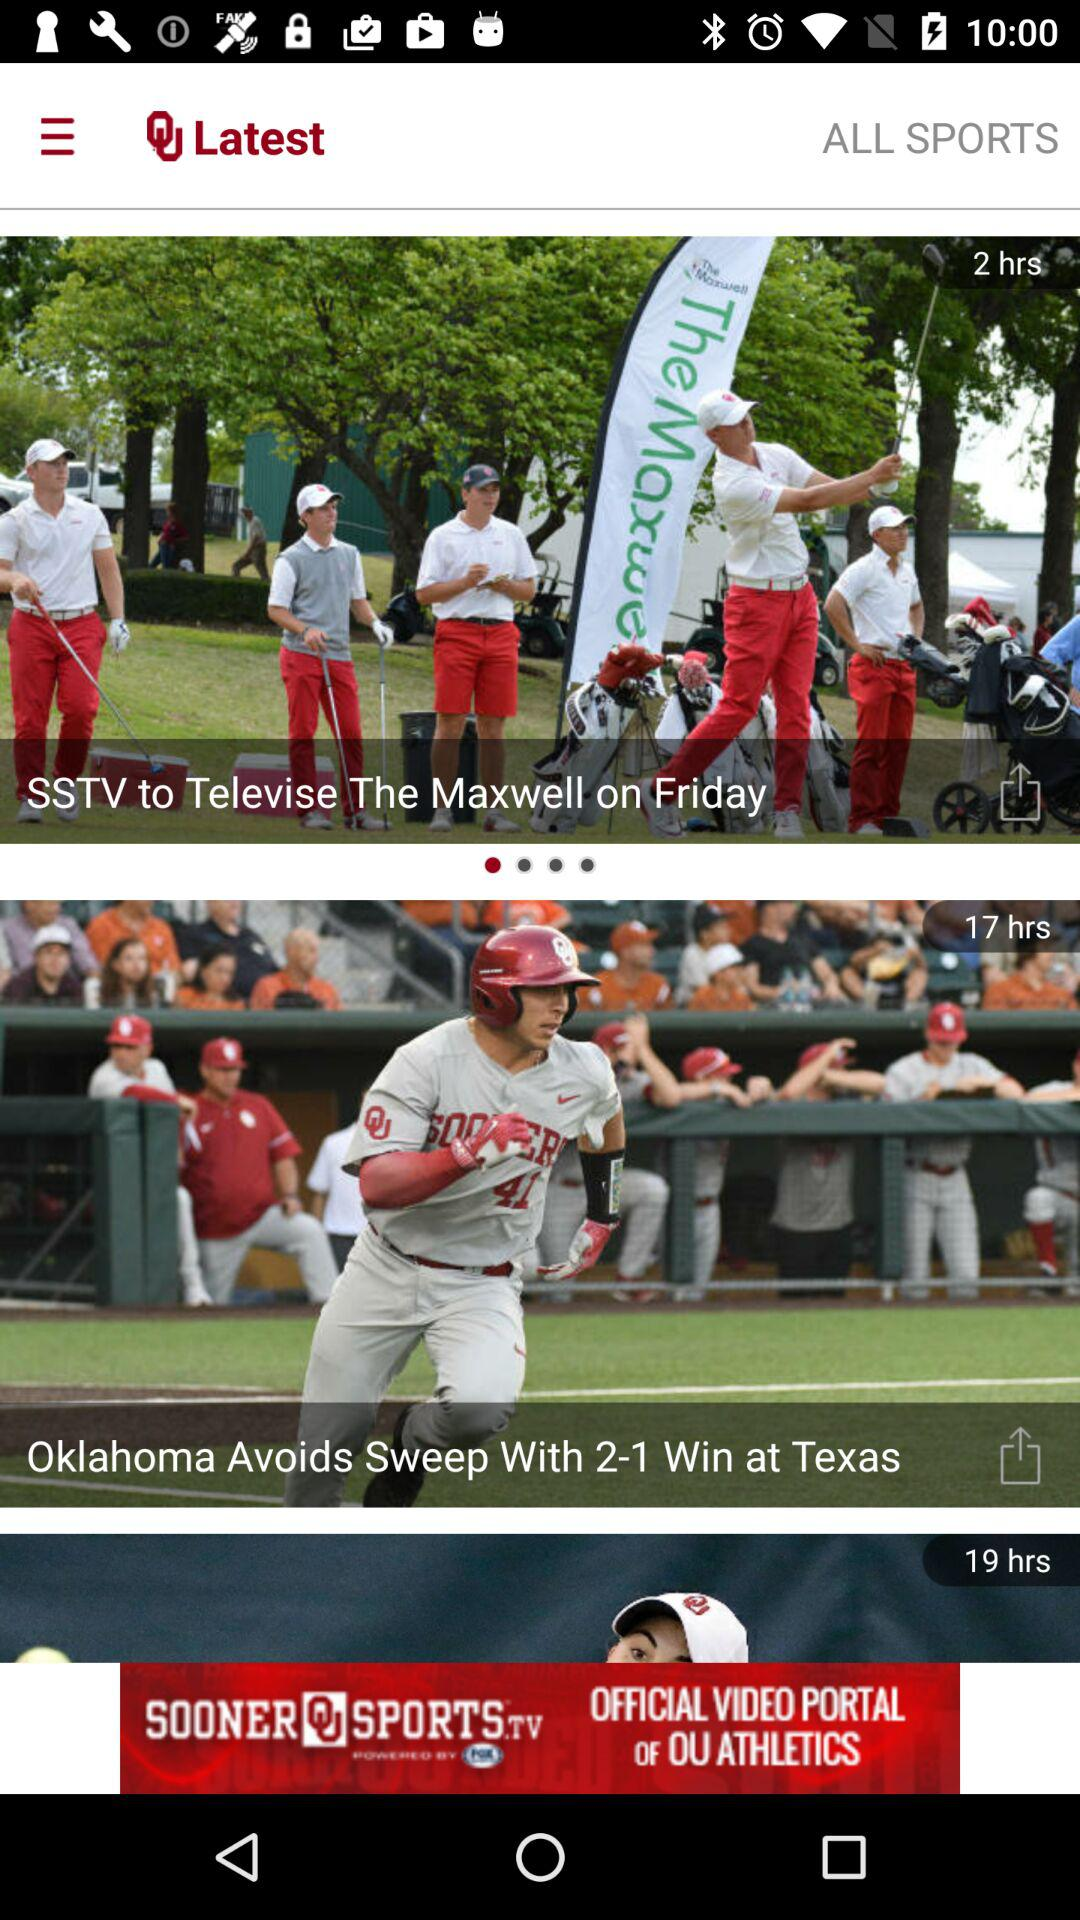How many hours ago was the news "SSTV to Televise The Maxwell on Friday" posted? The news was posted 2 hours ago. 